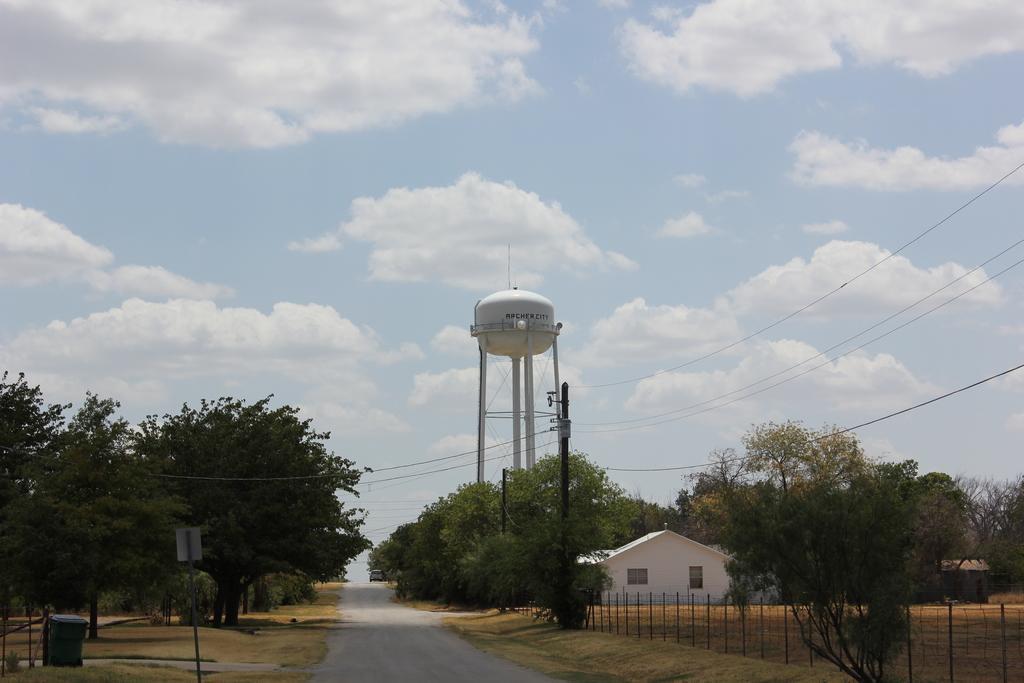Can you describe this image briefly? In the image I can see a house, tank and around there are some trees and plants. 